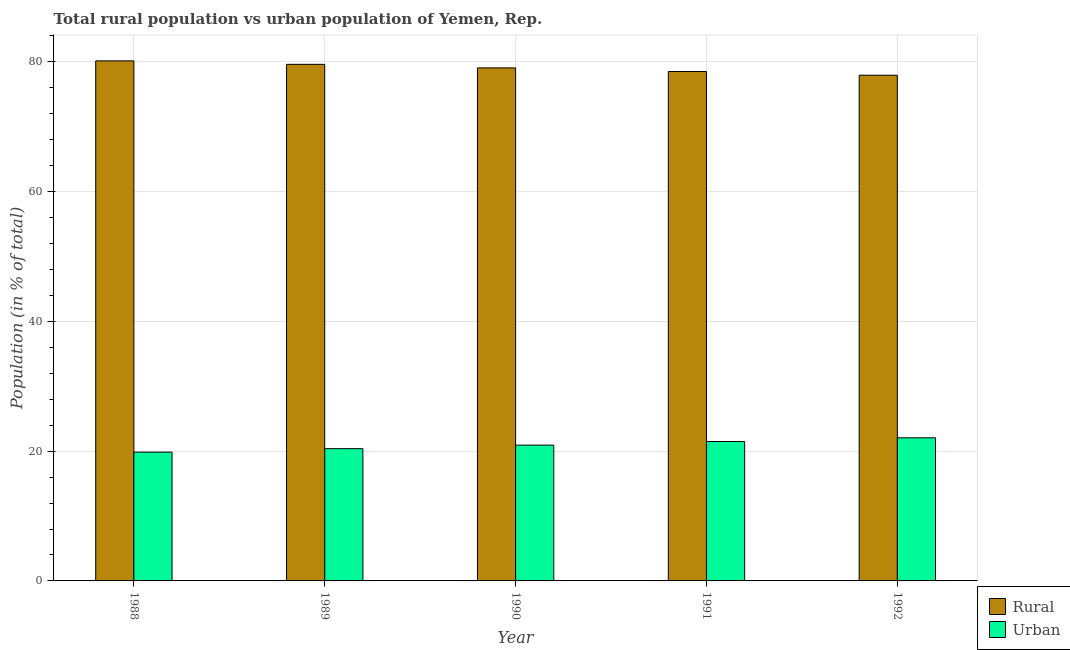How many different coloured bars are there?
Ensure brevity in your answer.  2. Are the number of bars on each tick of the X-axis equal?
Make the answer very short. Yes. How many bars are there on the 2nd tick from the left?
Your answer should be compact. 2. How many bars are there on the 4th tick from the right?
Offer a terse response. 2. What is the label of the 1st group of bars from the left?
Make the answer very short. 1988. What is the urban population in 1992?
Provide a succinct answer. 22.06. Across all years, what is the maximum urban population?
Your answer should be very brief. 22.06. Across all years, what is the minimum urban population?
Your response must be concise. 19.85. What is the total urban population in the graph?
Offer a terse response. 104.71. What is the difference between the rural population in 1988 and that in 1990?
Give a very brief answer. 1.08. What is the difference between the rural population in 1991 and the urban population in 1989?
Make the answer very short. -1.1. What is the average urban population per year?
Give a very brief answer. 20.94. In the year 1991, what is the difference between the rural population and urban population?
Your answer should be very brief. 0. In how many years, is the rural population greater than 16 %?
Provide a succinct answer. 5. What is the ratio of the urban population in 1988 to that in 1991?
Offer a terse response. 0.92. Is the urban population in 1988 less than that in 1990?
Keep it short and to the point. Yes. Is the difference between the urban population in 1989 and 1991 greater than the difference between the rural population in 1989 and 1991?
Give a very brief answer. No. What is the difference between the highest and the second highest urban population?
Your answer should be compact. 0.57. What is the difference between the highest and the lowest urban population?
Ensure brevity in your answer.  2.21. In how many years, is the rural population greater than the average rural population taken over all years?
Offer a very short reply. 3. Is the sum of the rural population in 1990 and 1992 greater than the maximum urban population across all years?
Provide a succinct answer. Yes. What does the 1st bar from the left in 1990 represents?
Provide a succinct answer. Rural. What does the 2nd bar from the right in 1989 represents?
Your response must be concise. Rural. How many bars are there?
Offer a terse response. 10. Are the values on the major ticks of Y-axis written in scientific E-notation?
Keep it short and to the point. No. What is the title of the graph?
Your response must be concise. Total rural population vs urban population of Yemen, Rep. Does "Highest 10% of population" appear as one of the legend labels in the graph?
Your answer should be compact. No. What is the label or title of the Y-axis?
Make the answer very short. Population (in % of total). What is the Population (in % of total) in Rural in 1988?
Give a very brief answer. 80.15. What is the Population (in % of total) of Urban in 1988?
Provide a short and direct response. 19.85. What is the Population (in % of total) of Rural in 1989?
Your answer should be very brief. 79.61. What is the Population (in % of total) of Urban in 1989?
Offer a very short reply. 20.39. What is the Population (in % of total) of Rural in 1990?
Provide a succinct answer. 79.07. What is the Population (in % of total) in Urban in 1990?
Provide a succinct answer. 20.93. What is the Population (in % of total) in Rural in 1991?
Make the answer very short. 78.51. What is the Population (in % of total) in Urban in 1991?
Give a very brief answer. 21.49. What is the Population (in % of total) in Rural in 1992?
Provide a short and direct response. 77.94. What is the Population (in % of total) in Urban in 1992?
Your response must be concise. 22.06. Across all years, what is the maximum Population (in % of total) in Rural?
Keep it short and to the point. 80.15. Across all years, what is the maximum Population (in % of total) of Urban?
Offer a very short reply. 22.06. Across all years, what is the minimum Population (in % of total) of Rural?
Your answer should be compact. 77.94. Across all years, what is the minimum Population (in % of total) of Urban?
Make the answer very short. 19.85. What is the total Population (in % of total) in Rural in the graph?
Provide a succinct answer. 395.29. What is the total Population (in % of total) in Urban in the graph?
Your response must be concise. 104.71. What is the difference between the Population (in % of total) of Rural in 1988 and that in 1989?
Give a very brief answer. 0.54. What is the difference between the Population (in % of total) in Urban in 1988 and that in 1989?
Keep it short and to the point. -0.54. What is the difference between the Population (in % of total) in Rural in 1988 and that in 1990?
Provide a short and direct response. 1.08. What is the difference between the Population (in % of total) in Urban in 1988 and that in 1990?
Keep it short and to the point. -1.08. What is the difference between the Population (in % of total) of Rural in 1988 and that in 1991?
Provide a short and direct response. 1.64. What is the difference between the Population (in % of total) of Urban in 1988 and that in 1991?
Provide a succinct answer. -1.64. What is the difference between the Population (in % of total) of Rural in 1988 and that in 1992?
Offer a terse response. 2.21. What is the difference between the Population (in % of total) in Urban in 1988 and that in 1992?
Provide a short and direct response. -2.21. What is the difference between the Population (in % of total) of Rural in 1989 and that in 1990?
Provide a short and direct response. 0.55. What is the difference between the Population (in % of total) of Urban in 1989 and that in 1990?
Your response must be concise. -0.55. What is the difference between the Population (in % of total) of Rural in 1989 and that in 1991?
Provide a succinct answer. 1.1. What is the difference between the Population (in % of total) in Urban in 1989 and that in 1991?
Make the answer very short. -1.1. What is the difference between the Population (in % of total) in Rural in 1989 and that in 1992?
Offer a very short reply. 1.67. What is the difference between the Population (in % of total) of Urban in 1989 and that in 1992?
Make the answer very short. -1.67. What is the difference between the Population (in % of total) of Rural in 1990 and that in 1991?
Your response must be concise. 0.56. What is the difference between the Population (in % of total) in Urban in 1990 and that in 1991?
Provide a short and direct response. -0.56. What is the difference between the Population (in % of total) in Rural in 1990 and that in 1992?
Your response must be concise. 1.13. What is the difference between the Population (in % of total) in Urban in 1990 and that in 1992?
Your answer should be compact. -1.13. What is the difference between the Population (in % of total) in Rural in 1991 and that in 1992?
Your answer should be compact. 0.57. What is the difference between the Population (in % of total) in Urban in 1991 and that in 1992?
Your answer should be compact. -0.57. What is the difference between the Population (in % of total) of Rural in 1988 and the Population (in % of total) of Urban in 1989?
Your answer should be very brief. 59.77. What is the difference between the Population (in % of total) of Rural in 1988 and the Population (in % of total) of Urban in 1990?
Keep it short and to the point. 59.22. What is the difference between the Population (in % of total) in Rural in 1988 and the Population (in % of total) in Urban in 1991?
Your response must be concise. 58.66. What is the difference between the Population (in % of total) in Rural in 1988 and the Population (in % of total) in Urban in 1992?
Make the answer very short. 58.09. What is the difference between the Population (in % of total) in Rural in 1989 and the Population (in % of total) in Urban in 1990?
Keep it short and to the point. 58.68. What is the difference between the Population (in % of total) in Rural in 1989 and the Population (in % of total) in Urban in 1991?
Make the answer very short. 58.13. What is the difference between the Population (in % of total) of Rural in 1989 and the Population (in % of total) of Urban in 1992?
Give a very brief answer. 57.56. What is the difference between the Population (in % of total) of Rural in 1990 and the Population (in % of total) of Urban in 1991?
Provide a succinct answer. 57.58. What is the difference between the Population (in % of total) in Rural in 1990 and the Population (in % of total) in Urban in 1992?
Offer a terse response. 57.01. What is the difference between the Population (in % of total) in Rural in 1991 and the Population (in % of total) in Urban in 1992?
Give a very brief answer. 56.45. What is the average Population (in % of total) in Rural per year?
Your response must be concise. 79.06. What is the average Population (in % of total) in Urban per year?
Your response must be concise. 20.94. In the year 1988, what is the difference between the Population (in % of total) of Rural and Population (in % of total) of Urban?
Make the answer very short. 60.3. In the year 1989, what is the difference between the Population (in % of total) of Rural and Population (in % of total) of Urban?
Give a very brief answer. 59.23. In the year 1990, what is the difference between the Population (in % of total) of Rural and Population (in % of total) of Urban?
Provide a short and direct response. 58.14. In the year 1991, what is the difference between the Population (in % of total) in Rural and Population (in % of total) in Urban?
Offer a terse response. 57.02. In the year 1992, what is the difference between the Population (in % of total) in Rural and Population (in % of total) in Urban?
Your answer should be very brief. 55.88. What is the ratio of the Population (in % of total) of Urban in 1988 to that in 1989?
Keep it short and to the point. 0.97. What is the ratio of the Population (in % of total) of Rural in 1988 to that in 1990?
Make the answer very short. 1.01. What is the ratio of the Population (in % of total) of Urban in 1988 to that in 1990?
Offer a terse response. 0.95. What is the ratio of the Population (in % of total) of Rural in 1988 to that in 1991?
Give a very brief answer. 1.02. What is the ratio of the Population (in % of total) in Urban in 1988 to that in 1991?
Provide a short and direct response. 0.92. What is the ratio of the Population (in % of total) of Rural in 1988 to that in 1992?
Your answer should be compact. 1.03. What is the ratio of the Population (in % of total) in Urban in 1988 to that in 1992?
Keep it short and to the point. 0.9. What is the ratio of the Population (in % of total) of Urban in 1989 to that in 1990?
Provide a succinct answer. 0.97. What is the ratio of the Population (in % of total) in Rural in 1989 to that in 1991?
Your answer should be very brief. 1.01. What is the ratio of the Population (in % of total) in Urban in 1989 to that in 1991?
Ensure brevity in your answer.  0.95. What is the ratio of the Population (in % of total) of Rural in 1989 to that in 1992?
Offer a very short reply. 1.02. What is the ratio of the Population (in % of total) in Urban in 1989 to that in 1992?
Your answer should be very brief. 0.92. What is the ratio of the Population (in % of total) of Rural in 1990 to that in 1991?
Give a very brief answer. 1.01. What is the ratio of the Population (in % of total) of Rural in 1990 to that in 1992?
Provide a short and direct response. 1.01. What is the ratio of the Population (in % of total) in Urban in 1990 to that in 1992?
Offer a very short reply. 0.95. What is the ratio of the Population (in % of total) in Rural in 1991 to that in 1992?
Your answer should be compact. 1.01. What is the ratio of the Population (in % of total) of Urban in 1991 to that in 1992?
Make the answer very short. 0.97. What is the difference between the highest and the second highest Population (in % of total) of Rural?
Provide a succinct answer. 0.54. What is the difference between the highest and the second highest Population (in % of total) in Urban?
Offer a very short reply. 0.57. What is the difference between the highest and the lowest Population (in % of total) of Rural?
Keep it short and to the point. 2.21. What is the difference between the highest and the lowest Population (in % of total) in Urban?
Your response must be concise. 2.21. 